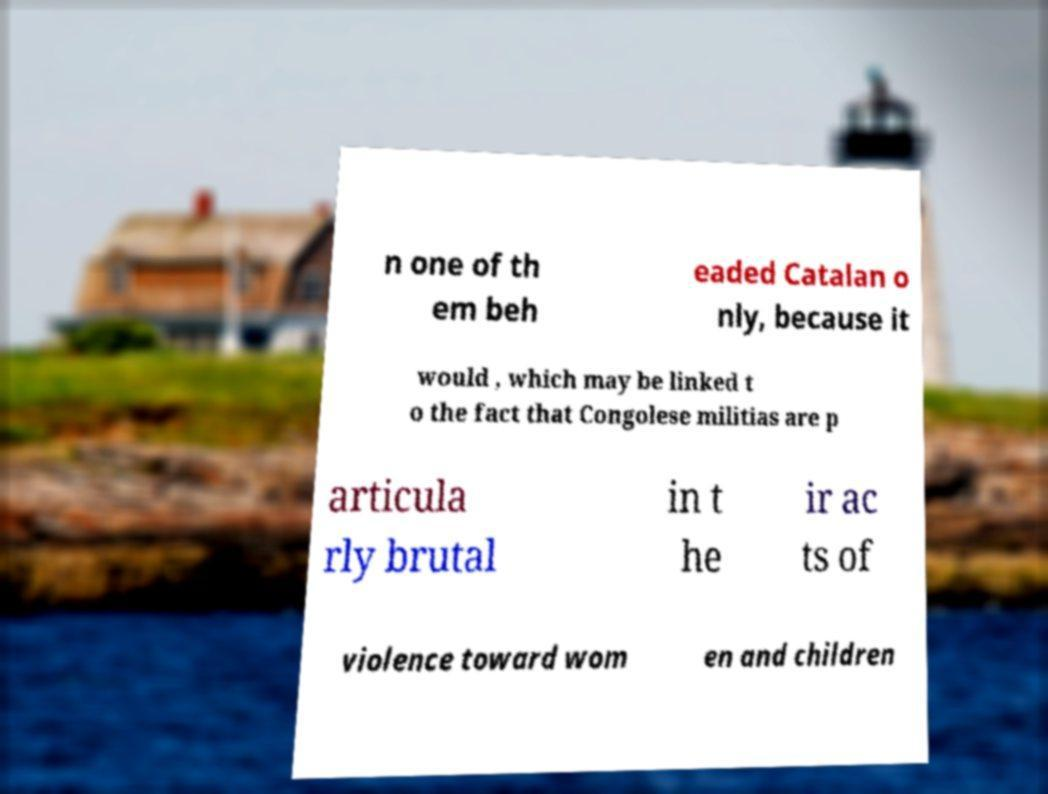Can you read and provide the text displayed in the image?This photo seems to have some interesting text. Can you extract and type it out for me? n one of th em beh eaded Catalan o nly, because it would , which may be linked t o the fact that Congolese militias are p articula rly brutal in t he ir ac ts of violence toward wom en and children 